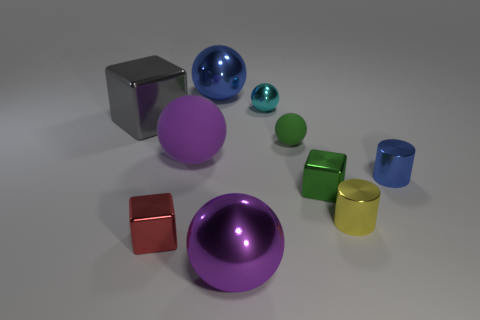Subtract all green balls. How many balls are left? 4 Subtract all small cyan spheres. How many spheres are left? 4 Subtract 2 spheres. How many spheres are left? 3 Subtract all cyan balls. Subtract all gray blocks. How many balls are left? 4 Subtract all cubes. How many objects are left? 7 Add 8 tiny red objects. How many tiny red objects are left? 9 Add 4 big brown matte spheres. How many big brown matte spheres exist? 4 Subtract 0 red balls. How many objects are left? 10 Subtract all large rubber balls. Subtract all rubber spheres. How many objects are left? 7 